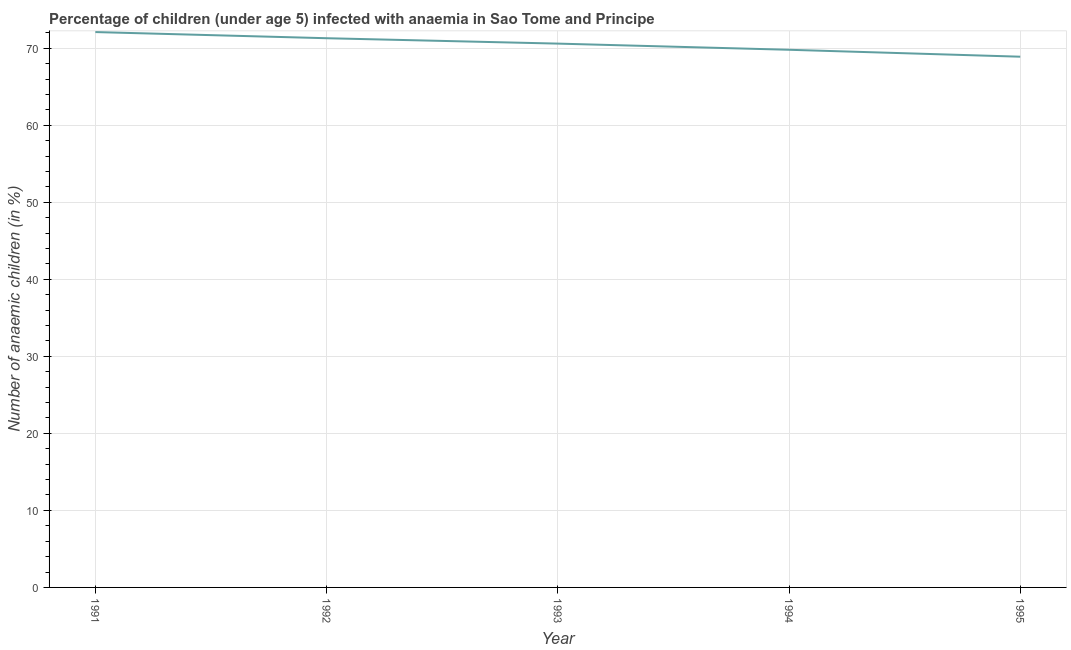What is the number of anaemic children in 1995?
Your answer should be compact. 68.9. Across all years, what is the maximum number of anaemic children?
Make the answer very short. 72.1. Across all years, what is the minimum number of anaemic children?
Offer a very short reply. 68.9. What is the sum of the number of anaemic children?
Provide a succinct answer. 352.7. What is the difference between the number of anaemic children in 1991 and 1995?
Provide a short and direct response. 3.2. What is the average number of anaemic children per year?
Your answer should be compact. 70.54. What is the median number of anaemic children?
Your response must be concise. 70.6. In how many years, is the number of anaemic children greater than 20 %?
Provide a short and direct response. 5. What is the ratio of the number of anaemic children in 1992 to that in 1993?
Give a very brief answer. 1.01. Is the number of anaemic children in 1993 less than that in 1995?
Offer a very short reply. No. Is the difference between the number of anaemic children in 1991 and 1992 greater than the difference between any two years?
Give a very brief answer. No. What is the difference between the highest and the second highest number of anaemic children?
Offer a very short reply. 0.8. Is the sum of the number of anaemic children in 1994 and 1995 greater than the maximum number of anaemic children across all years?
Keep it short and to the point. Yes. What is the difference between the highest and the lowest number of anaemic children?
Your response must be concise. 3.2. In how many years, is the number of anaemic children greater than the average number of anaemic children taken over all years?
Your answer should be very brief. 3. How many lines are there?
Ensure brevity in your answer.  1. Are the values on the major ticks of Y-axis written in scientific E-notation?
Offer a very short reply. No. Does the graph contain grids?
Provide a succinct answer. Yes. What is the title of the graph?
Make the answer very short. Percentage of children (under age 5) infected with anaemia in Sao Tome and Principe. What is the label or title of the X-axis?
Ensure brevity in your answer.  Year. What is the label or title of the Y-axis?
Give a very brief answer. Number of anaemic children (in %). What is the Number of anaemic children (in %) of 1991?
Offer a very short reply. 72.1. What is the Number of anaemic children (in %) in 1992?
Keep it short and to the point. 71.3. What is the Number of anaemic children (in %) in 1993?
Offer a very short reply. 70.6. What is the Number of anaemic children (in %) of 1994?
Your answer should be very brief. 69.8. What is the Number of anaemic children (in %) of 1995?
Your answer should be very brief. 68.9. What is the difference between the Number of anaemic children (in %) in 1991 and 1992?
Provide a succinct answer. 0.8. What is the difference between the Number of anaemic children (in %) in 1992 and 1993?
Your answer should be compact. 0.7. What is the difference between the Number of anaemic children (in %) in 1992 and 1994?
Your response must be concise. 1.5. What is the difference between the Number of anaemic children (in %) in 1993 and 1995?
Offer a very short reply. 1.7. What is the difference between the Number of anaemic children (in %) in 1994 and 1995?
Offer a terse response. 0.9. What is the ratio of the Number of anaemic children (in %) in 1991 to that in 1993?
Offer a very short reply. 1.02. What is the ratio of the Number of anaemic children (in %) in 1991 to that in 1994?
Ensure brevity in your answer.  1.03. What is the ratio of the Number of anaemic children (in %) in 1991 to that in 1995?
Offer a very short reply. 1.05. What is the ratio of the Number of anaemic children (in %) in 1992 to that in 1993?
Provide a short and direct response. 1.01. What is the ratio of the Number of anaemic children (in %) in 1992 to that in 1994?
Give a very brief answer. 1.02. What is the ratio of the Number of anaemic children (in %) in 1992 to that in 1995?
Ensure brevity in your answer.  1.03. What is the ratio of the Number of anaemic children (in %) in 1993 to that in 1994?
Make the answer very short. 1.01. 